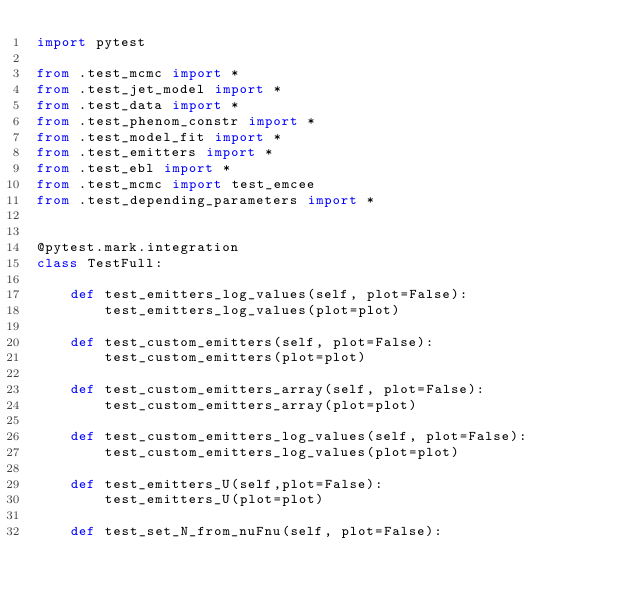Convert code to text. <code><loc_0><loc_0><loc_500><loc_500><_Python_>import pytest

from .test_mcmc import *
from .test_jet_model import *
from .test_data import *
from .test_phenom_constr import *
from .test_model_fit import *
from .test_emitters import *
from .test_ebl import *
from .test_mcmc import test_emcee
from .test_depending_parameters import *


@pytest.mark.integration
class TestFull:

    def test_emitters_log_values(self, plot=False):
        test_emitters_log_values(plot=plot)

    def test_custom_emitters(self, plot=False):
        test_custom_emitters(plot=plot)

    def test_custom_emitters_array(self, plot=False):
        test_custom_emitters_array(plot=plot)

    def test_custom_emitters_log_values(self, plot=False):
        test_custom_emitters_log_values(plot=plot)

    def test_emitters_U(self,plot=False):
        test_emitters_U(plot=plot)

    def test_set_N_from_nuFnu(self, plot=False):</code> 